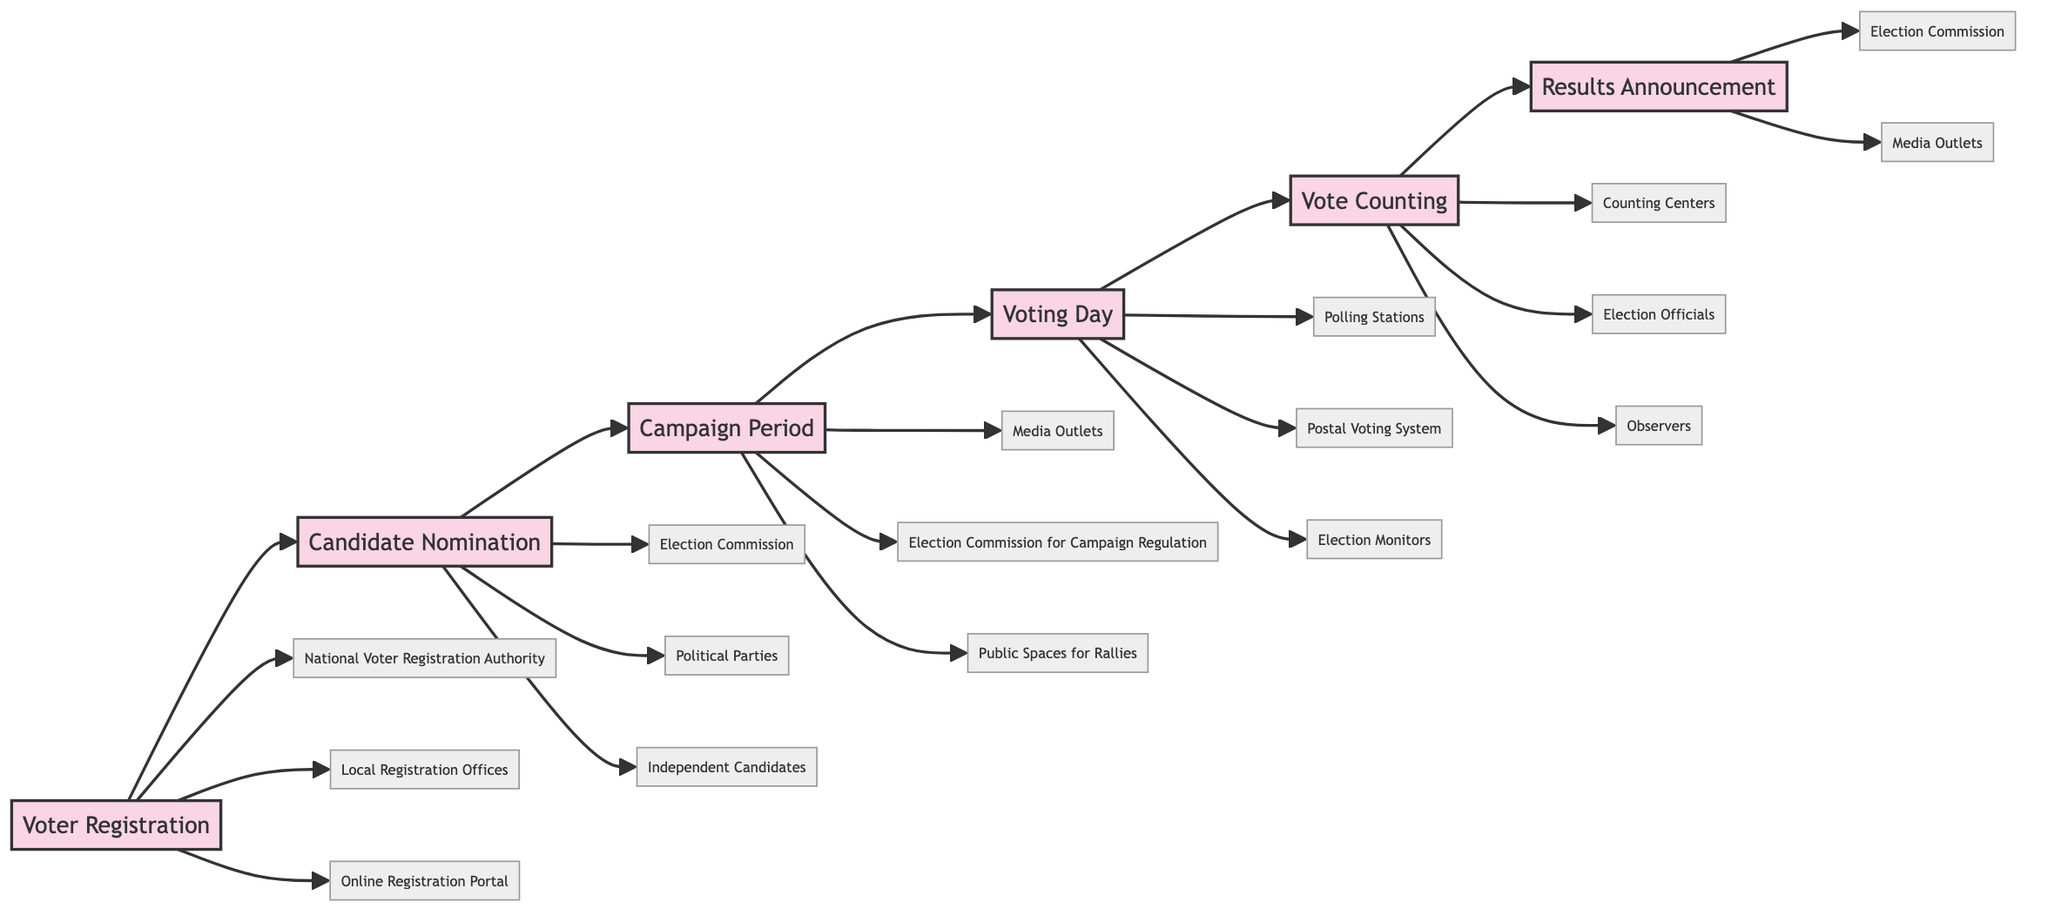What is the first stage in the electoral process? The first stage listed in the diagram is "Voter Registration." This can be inferred as it is the starting point of the flowchart with an arrow pointing to the next stage.
Answer: Voter Registration How many entities are associated with the "Voting Day" stage? In the diagram, the "Voting Day" stage points to three entities: "Polling Stations," "Postal Voting System," and "Election Monitors." Counting these gives us three entities associated with this stage.
Answer: 3 Which two entities are connected to the "Results Announcement" stage? The "Results Announcement" stage has two entities connected: "Election Commission" and "Media Outlets." This can be identified by following the flowchart's arrows leading from the stage to the entities.
Answer: Election Commission, Media Outlets What comes directly after "Vote Counting"? Following the arrows in the flowchart, "Results Announcement" is the stage that comes directly after "Vote Counting." This sequential relationship indicates the next step in the electoral process.
Answer: Results Announcement Which stage involves candidates and parties campaigning? The "Campaign Period" stage is the one where candidates and parties campaign via media, rallies, and debates. The relevant description under this stage confirms the campaigning activities happen here.
Answer: Campaign Period How many total stages are depicted in the diagram? By counting the stages listed in the flowchart, there are six distinct stages in total: "Voter Registration," "Candidate Nomination," "Campaign Period," "Voting Day," "Vote Counting," and "Results Announcement."
Answer: 6 What entity regulates campaigning during the "Campaign Period"? The entity responsible for regulating campaigning during the "Campaign Period" is the "Election Commission for Campaign Regulation." This is indicated by the arrow from the "Campaign Period" stage leading to this entity.
Answer: Election Commission for Campaign Regulation What stage precedes "Voting Day"? The stage that immediately precedes "Voting Day," according to the flow of the diagram, is "Campaign Period." This can be seen by following the arrows from one stage to the next in the flowchart.
Answer: Campaign Period 